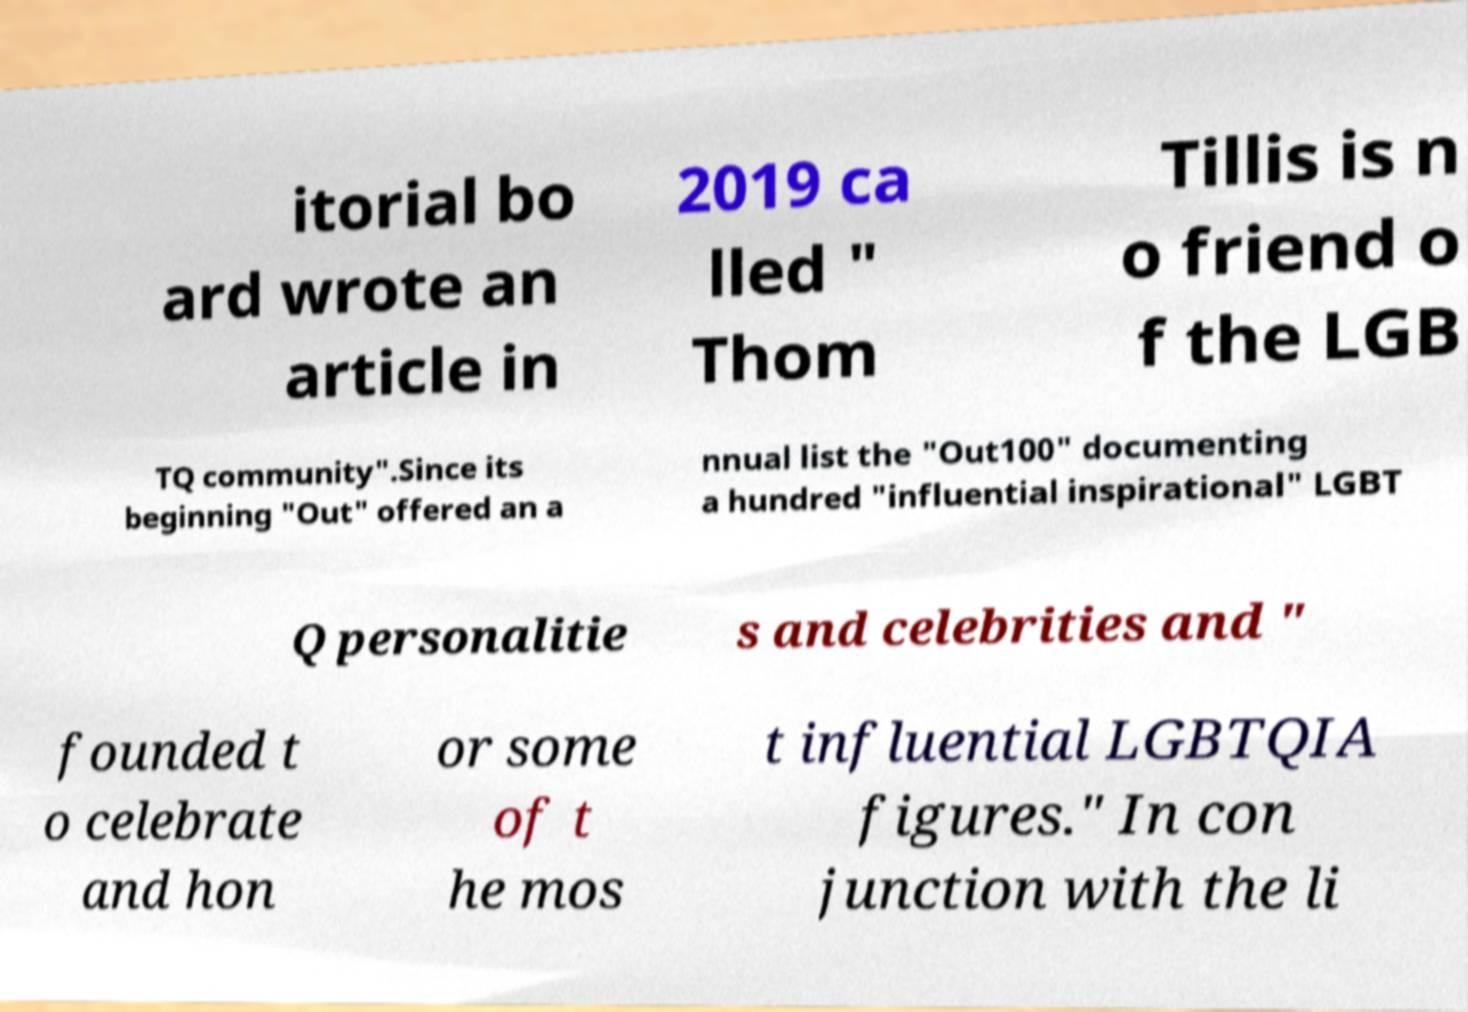Could you extract and type out the text from this image? itorial bo ard wrote an article in 2019 ca lled " Thom Tillis is n o friend o f the LGB TQ community".Since its beginning "Out" offered an a nnual list the "Out100" documenting a hundred "influential inspirational" LGBT Q personalitie s and celebrities and " founded t o celebrate and hon or some of t he mos t influential LGBTQIA figures." In con junction with the li 